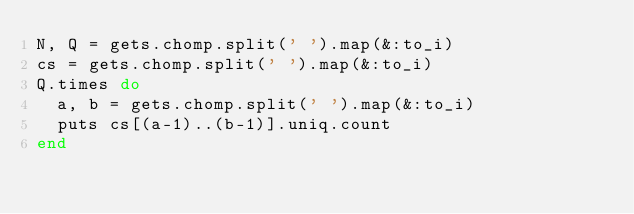<code> <loc_0><loc_0><loc_500><loc_500><_Ruby_>N, Q = gets.chomp.split(' ').map(&:to_i)
cs = gets.chomp.split(' ').map(&:to_i)
Q.times do
  a, b = gets.chomp.split(' ').map(&:to_i)
  puts cs[(a-1)..(b-1)].uniq.count
end</code> 